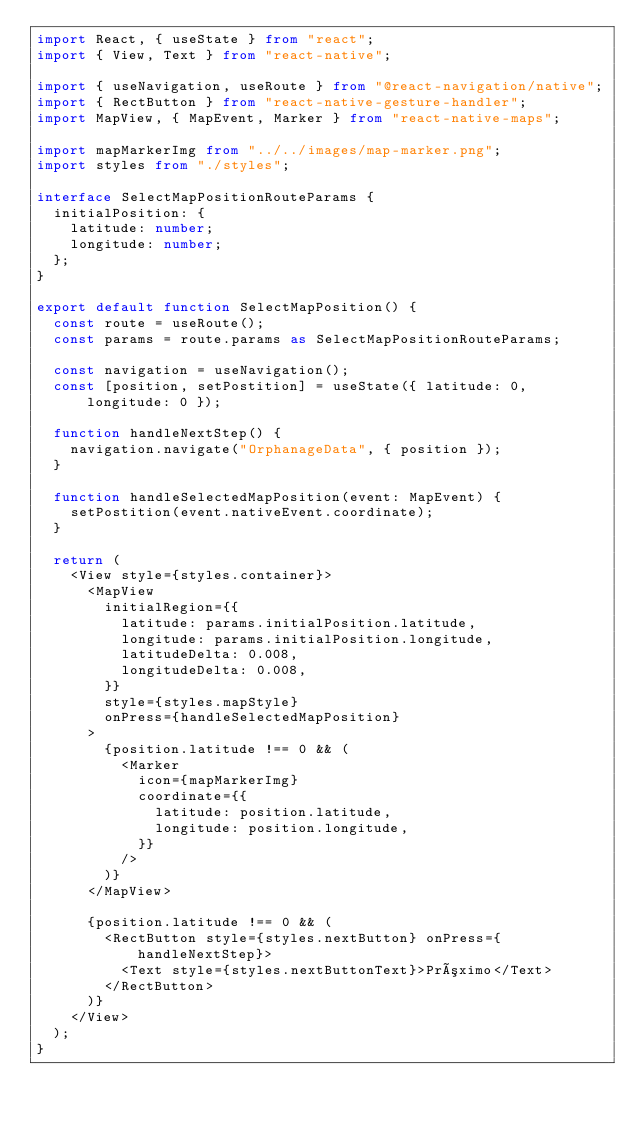<code> <loc_0><loc_0><loc_500><loc_500><_TypeScript_>import React, { useState } from "react";
import { View, Text } from "react-native";

import { useNavigation, useRoute } from "@react-navigation/native";
import { RectButton } from "react-native-gesture-handler";
import MapView, { MapEvent, Marker } from "react-native-maps";

import mapMarkerImg from "../../images/map-marker.png";
import styles from "./styles";

interface SelectMapPositionRouteParams {
  initialPosition: {
    latitude: number;
    longitude: number;
  };
}

export default function SelectMapPosition() {
  const route = useRoute();
  const params = route.params as SelectMapPositionRouteParams;

  const navigation = useNavigation();
  const [position, setPostition] = useState({ latitude: 0, longitude: 0 });

  function handleNextStep() {
    navigation.navigate("OrphanageData", { position });
  }

  function handleSelectedMapPosition(event: MapEvent) {
    setPostition(event.nativeEvent.coordinate);
  }

  return (
    <View style={styles.container}>
      <MapView
        initialRegion={{
          latitude: params.initialPosition.latitude,
          longitude: params.initialPosition.longitude,
          latitudeDelta: 0.008,
          longitudeDelta: 0.008,
        }}
        style={styles.mapStyle}
        onPress={handleSelectedMapPosition}
      >
        {position.latitude !== 0 && (
          <Marker
            icon={mapMarkerImg}
            coordinate={{
              latitude: position.latitude,
              longitude: position.longitude,
            }}
          />
        )}
      </MapView>

      {position.latitude !== 0 && (
        <RectButton style={styles.nextButton} onPress={handleNextStep}>
          <Text style={styles.nextButtonText}>Próximo</Text>
        </RectButton>
      )}
    </View>
  );
}
</code> 